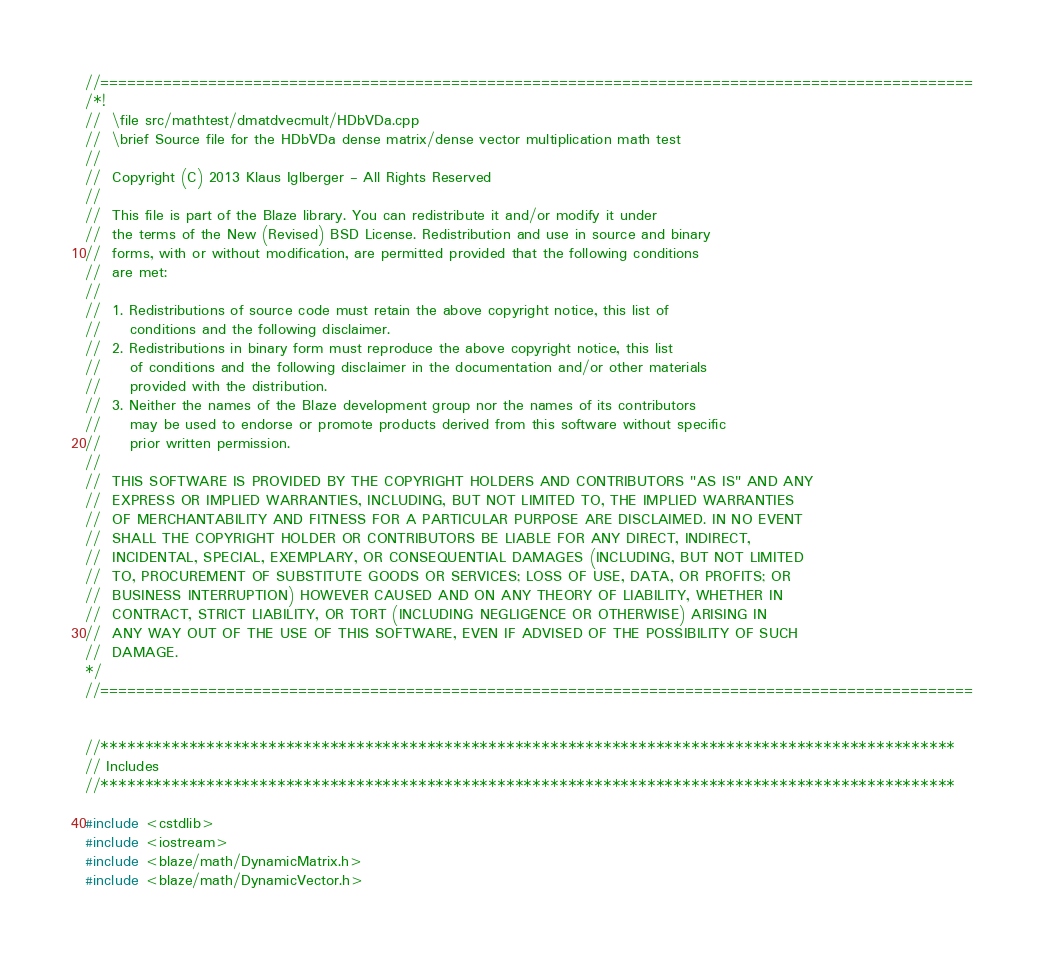Convert code to text. <code><loc_0><loc_0><loc_500><loc_500><_C++_>//=================================================================================================
/*!
//  \file src/mathtest/dmatdvecmult/HDbVDa.cpp
//  \brief Source file for the HDbVDa dense matrix/dense vector multiplication math test
//
//  Copyright (C) 2013 Klaus Iglberger - All Rights Reserved
//
//  This file is part of the Blaze library. You can redistribute it and/or modify it under
//  the terms of the New (Revised) BSD License. Redistribution and use in source and binary
//  forms, with or without modification, are permitted provided that the following conditions
//  are met:
//
//  1. Redistributions of source code must retain the above copyright notice, this list of
//     conditions and the following disclaimer.
//  2. Redistributions in binary form must reproduce the above copyright notice, this list
//     of conditions and the following disclaimer in the documentation and/or other materials
//     provided with the distribution.
//  3. Neither the names of the Blaze development group nor the names of its contributors
//     may be used to endorse or promote products derived from this software without specific
//     prior written permission.
//
//  THIS SOFTWARE IS PROVIDED BY THE COPYRIGHT HOLDERS AND CONTRIBUTORS "AS IS" AND ANY
//  EXPRESS OR IMPLIED WARRANTIES, INCLUDING, BUT NOT LIMITED TO, THE IMPLIED WARRANTIES
//  OF MERCHANTABILITY AND FITNESS FOR A PARTICULAR PURPOSE ARE DISCLAIMED. IN NO EVENT
//  SHALL THE COPYRIGHT HOLDER OR CONTRIBUTORS BE LIABLE FOR ANY DIRECT, INDIRECT,
//  INCIDENTAL, SPECIAL, EXEMPLARY, OR CONSEQUENTIAL DAMAGES (INCLUDING, BUT NOT LIMITED
//  TO, PROCUREMENT OF SUBSTITUTE GOODS OR SERVICES; LOSS OF USE, DATA, OR PROFITS; OR
//  BUSINESS INTERRUPTION) HOWEVER CAUSED AND ON ANY THEORY OF LIABILITY, WHETHER IN
//  CONTRACT, STRICT LIABILITY, OR TORT (INCLUDING NEGLIGENCE OR OTHERWISE) ARISING IN
//  ANY WAY OUT OF THE USE OF THIS SOFTWARE, EVEN IF ADVISED OF THE POSSIBILITY OF SUCH
//  DAMAGE.
*/
//=================================================================================================


//*************************************************************************************************
// Includes
//*************************************************************************************************

#include <cstdlib>
#include <iostream>
#include <blaze/math/DynamicMatrix.h>
#include <blaze/math/DynamicVector.h></code> 